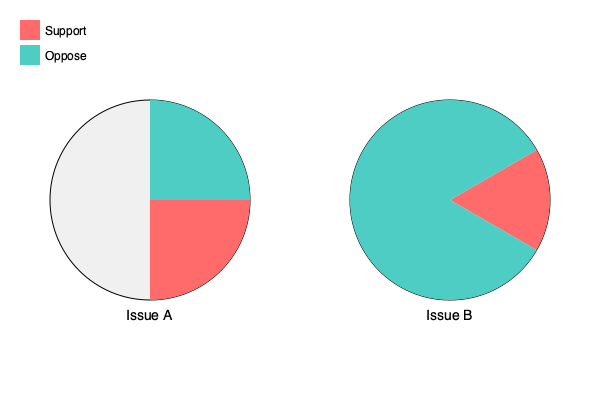Based on the pie charts representing voter support for two civil rights issues, which issue has a higher level of support, and by what percentage difference? To solve this question, we need to follow these steps:

1. Analyze Issue A:
   - Support: 3/4 of the circle = 75%
   - Oppose: 1/4 of the circle = 25%

2. Analyze Issue B:
   - Support: 1/3 of the circle = 33.33%
   - Oppose: 2/3 of the circle = 66.67%

3. Compare support levels:
   - Issue A support: 75%
   - Issue B support: 33.33%

4. Calculate the difference:
   $75\% - 33.33\% = 41.67\%$

5. Round to the nearest whole percentage:
   $41.67\% \approx 42\%$

Therefore, Issue A has a higher level of support, and the difference is approximately 42 percentage points.
Answer: Issue A, 42% 